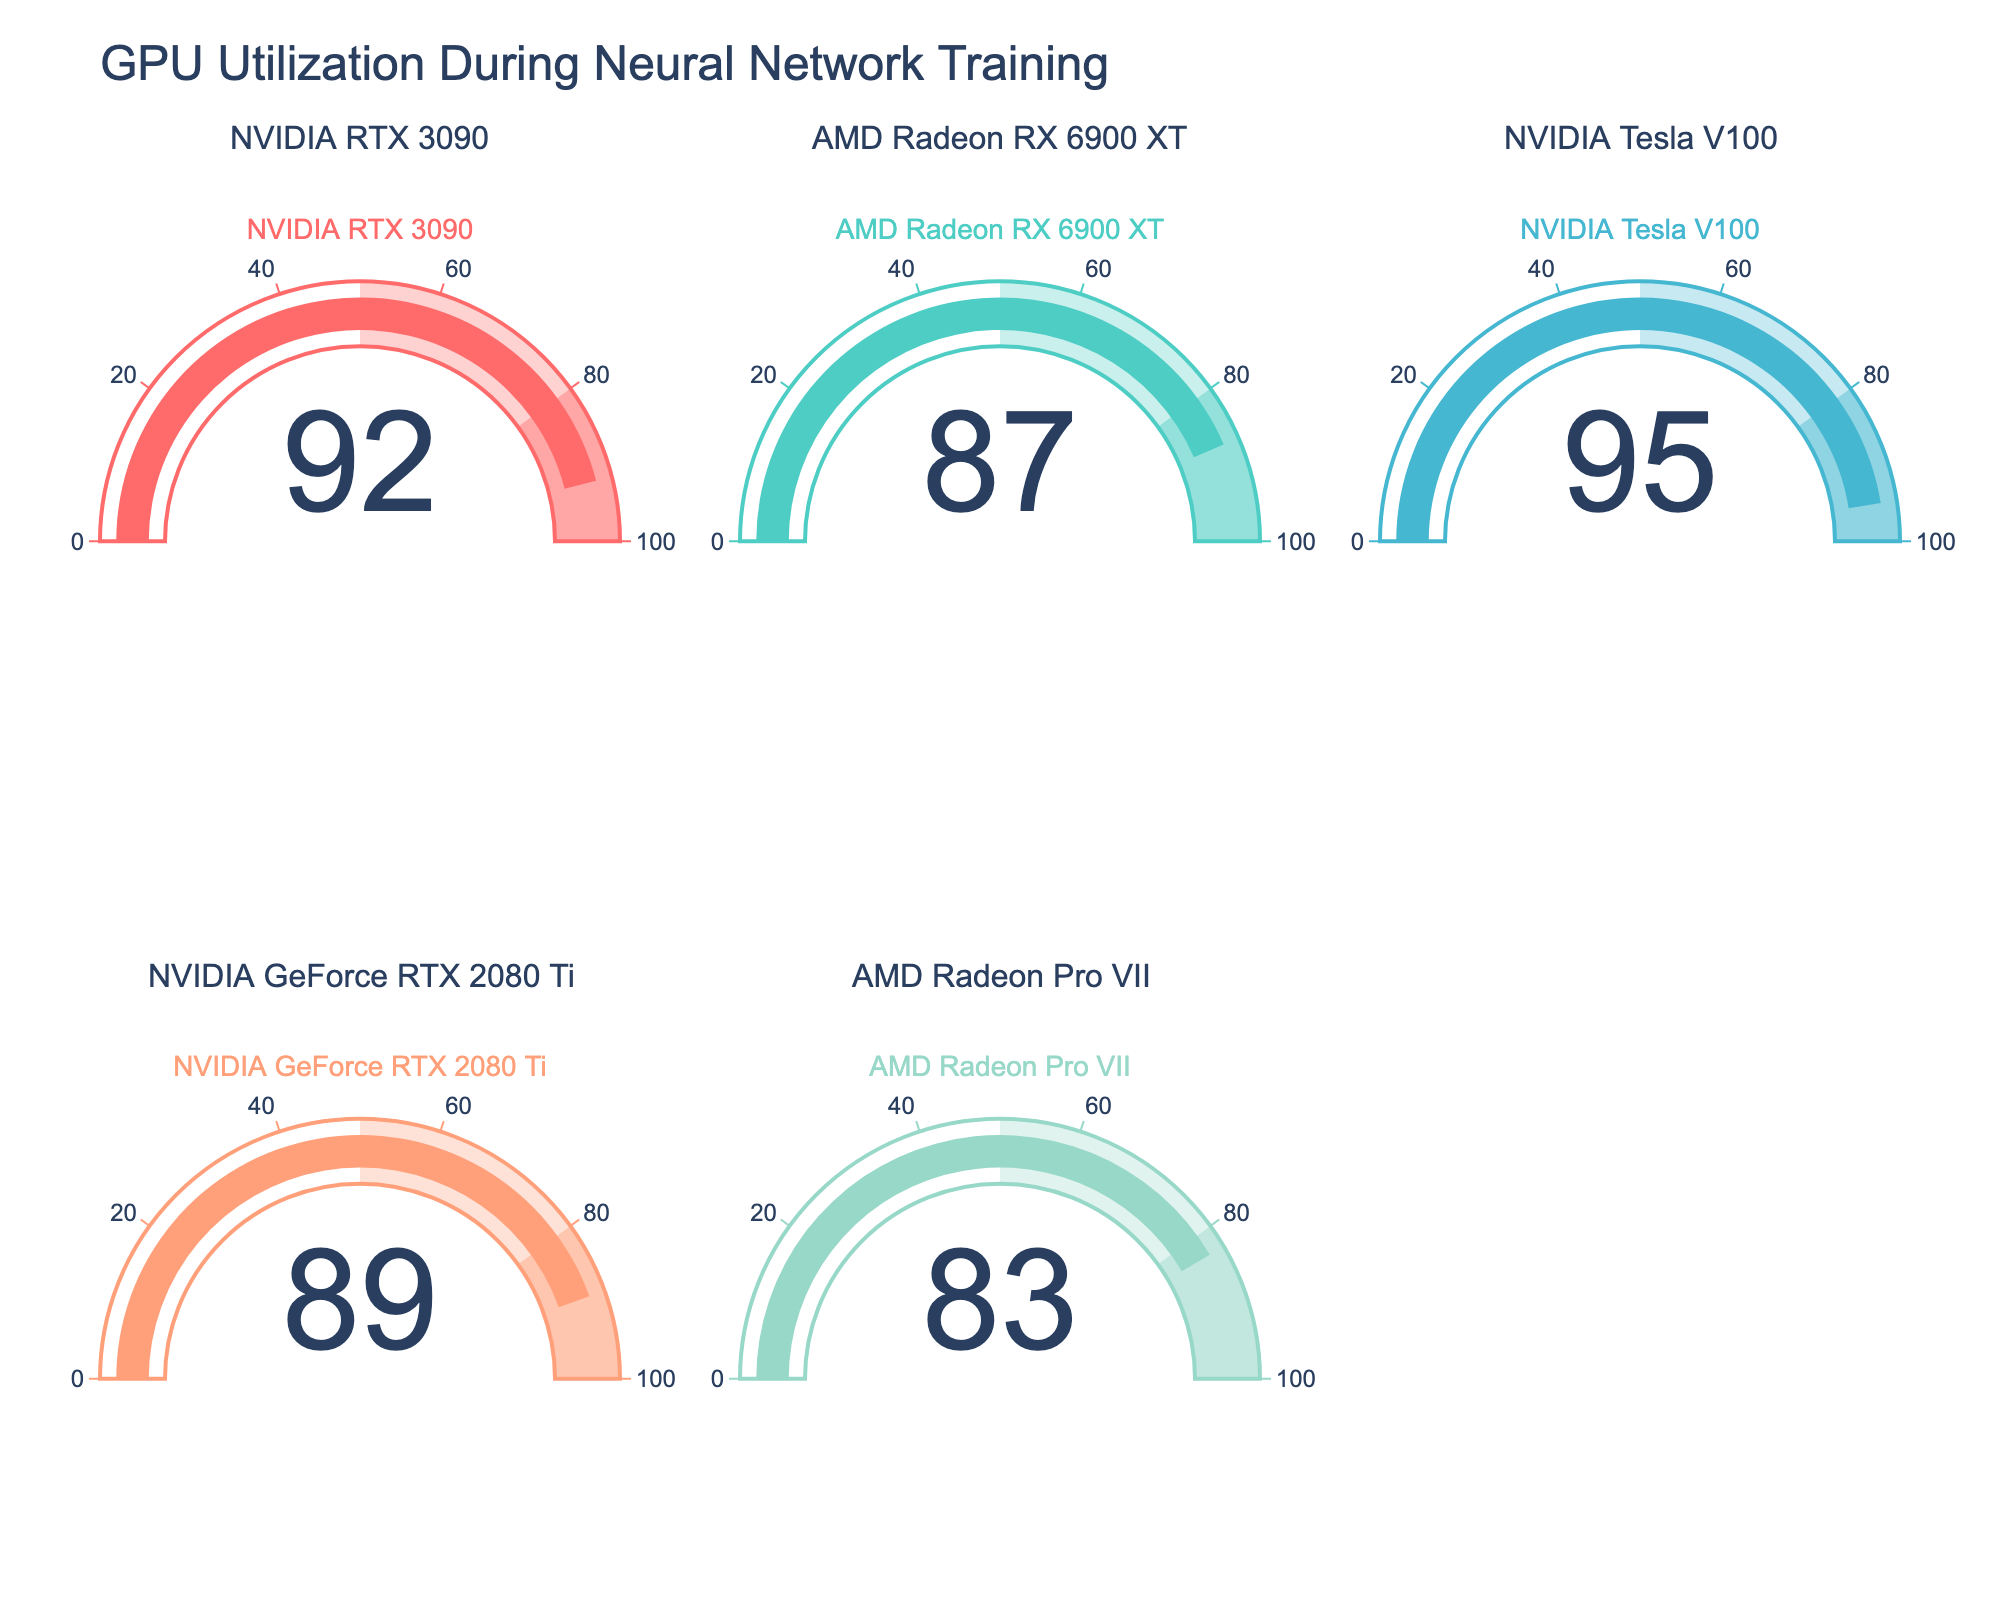How many GPUs have over 90% utilization? We can count the number of gauges that display a value over 90%. The GPUs with utilization percentages over 90% are NVIDIA RTX 3090 (92%) and NVIDIA Tesla V100 (95%).
Answer: 2 What is the GPU with the highest utilization percentage? By inspecting the gauge values, we see that the NVIDIA Tesla V100 has the highest utilization percentage of 95%.
Answer: NVIDIA Tesla V100 What is the difference in utilization percentage between the GPU with the highest and the lowest utilization? The GPU with the highest utilization is NVIDIA Tesla V100 at 95%, and the GPU with the lowest utilization is AMD Radeon Pro VII at 83%. The difference is 95% - 83% = 12%.
Answer: 12% What is the average utilization percentage of all GPUs shown? The utilization percentages are 92, 87, 95, 89, and 83. Sum these values to get 446 and then divide by the number of GPUs (5). The average is 446 / 5 = 89.2%.
Answer: 89.2% Which GPU has the second-highest utilization percentage? By examining the gauges, the highest utilization percentage is NVIDIA Tesla V100 at 95%. The second-highest utilization percentage belongs to NVIDIA RTX 3090 at 92%.
Answer: NVIDIA RTX 3090 What are the utilization percentages of AMD GPUs in the figure? There are two AMD GPUs: AMD Radeon RX 6900 XT with 87% utilization and AMD Radeon Pro VII with 83% utilization.
Answer: 87%, 83% Are there more GPUs with utilization percentages above or below 90%? There are two GPUs with utilization percentages above 90% (NVIDIA RTX 3090 and NVIDIA Tesla V100) and three GPUs with utilization percentages below 90% (AMD Radeon RX 6900 XT, NVIDIA GeForce RTX 2080 Ti, and AMD Radeon Pro VII). More GPUs have utilization percentages below 90%.
Answer: Below 90% What is the combined utilization percentage of NVIDIA GPUs? The NVIDIA GPUs and their utilization percentages are NVIDIA RTX 3090 (92%), NVIDIA Tesla V100 (95%), and NVIDIA GeForce RTX 2080 Ti (89%). The combined utilization is 92 + 95 + 89 = 276%.
Answer: 276% Which GPU has the closest utilization percentage to the average utilization? The average utilization is 89.2%. The GPUs closest to this value are NVIDIA GeForce RTX 2080 Ti at 89% and AMD Radeon RX 6900 XT at 87%. Among these, the NVIDIA GeForce RTX 2080 Ti is closer to 89.2%.
Answer: NVIDIA GeForce RTX 2080 Ti 